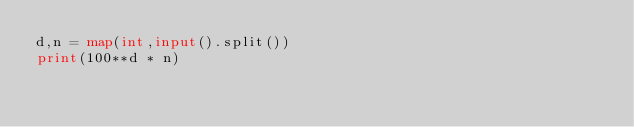<code> <loc_0><loc_0><loc_500><loc_500><_Python_>d,n = map(int,input().split())
print(100**d * n)
</code> 